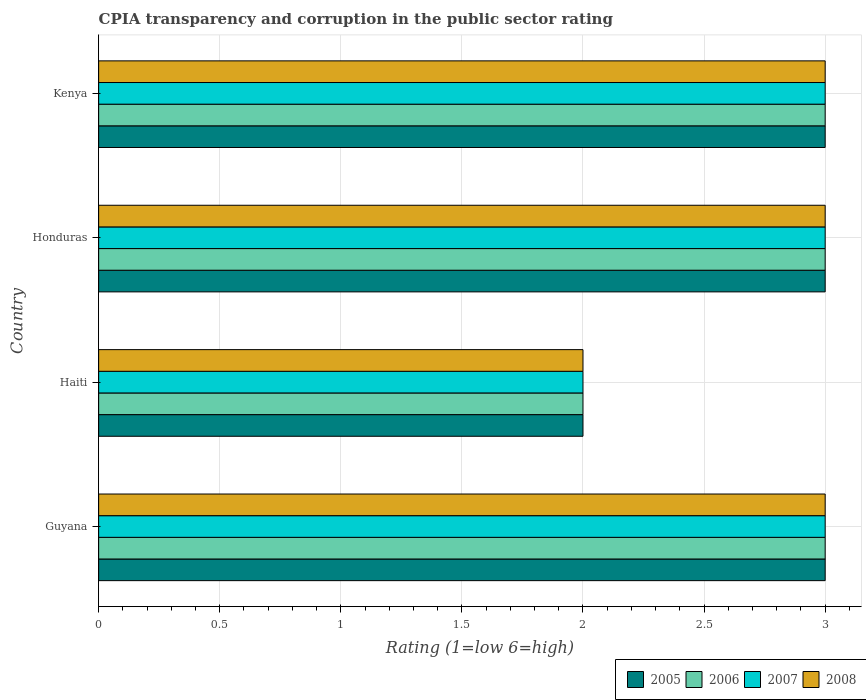How many groups of bars are there?
Provide a short and direct response. 4. How many bars are there on the 3rd tick from the top?
Make the answer very short. 4. What is the label of the 4th group of bars from the top?
Offer a terse response. Guyana. What is the CPIA rating in 2007 in Honduras?
Provide a short and direct response. 3. Across all countries, what is the minimum CPIA rating in 2006?
Provide a succinct answer. 2. In which country was the CPIA rating in 2007 maximum?
Your answer should be very brief. Guyana. In which country was the CPIA rating in 2007 minimum?
Your answer should be very brief. Haiti. What is the difference between the CPIA rating in 2008 in Haiti and that in Honduras?
Keep it short and to the point. -1. What is the difference between the CPIA rating in 2008 in Guyana and the CPIA rating in 2005 in Honduras?
Make the answer very short. 0. What is the average CPIA rating in 2005 per country?
Your answer should be compact. 2.75. In how many countries, is the CPIA rating in 2005 greater than 2.4 ?
Keep it short and to the point. 3. What is the ratio of the CPIA rating in 2008 in Honduras to that in Kenya?
Make the answer very short. 1. Is the CPIA rating in 2006 in Honduras less than that in Kenya?
Make the answer very short. No. Is the difference between the CPIA rating in 2006 in Guyana and Kenya greater than the difference between the CPIA rating in 2005 in Guyana and Kenya?
Offer a very short reply. No. What is the difference between the highest and the lowest CPIA rating in 2008?
Give a very brief answer. 1. In how many countries, is the CPIA rating in 2007 greater than the average CPIA rating in 2007 taken over all countries?
Keep it short and to the point. 3. Is the sum of the CPIA rating in 2007 in Haiti and Kenya greater than the maximum CPIA rating in 2008 across all countries?
Your answer should be very brief. Yes. Is it the case that in every country, the sum of the CPIA rating in 2006 and CPIA rating in 2005 is greater than the CPIA rating in 2008?
Offer a terse response. Yes. Are all the bars in the graph horizontal?
Keep it short and to the point. Yes. What is the difference between two consecutive major ticks on the X-axis?
Offer a terse response. 0.5. Does the graph contain any zero values?
Your response must be concise. No. Does the graph contain grids?
Offer a terse response. Yes. Where does the legend appear in the graph?
Your answer should be compact. Bottom right. What is the title of the graph?
Give a very brief answer. CPIA transparency and corruption in the public sector rating. What is the label or title of the Y-axis?
Make the answer very short. Country. What is the Rating (1=low 6=high) of 2008 in Guyana?
Your answer should be very brief. 3. What is the Rating (1=low 6=high) of 2007 in Haiti?
Provide a short and direct response. 2. What is the Rating (1=low 6=high) in 2005 in Honduras?
Offer a very short reply. 3. What is the Rating (1=low 6=high) in 2006 in Honduras?
Provide a short and direct response. 3. What is the Rating (1=low 6=high) in 2008 in Honduras?
Give a very brief answer. 3. What is the Rating (1=low 6=high) of 2008 in Kenya?
Your answer should be very brief. 3. Across all countries, what is the maximum Rating (1=low 6=high) in 2005?
Provide a succinct answer. 3. Across all countries, what is the maximum Rating (1=low 6=high) of 2006?
Provide a succinct answer. 3. Across all countries, what is the maximum Rating (1=low 6=high) of 2007?
Ensure brevity in your answer.  3. Across all countries, what is the minimum Rating (1=low 6=high) in 2006?
Offer a very short reply. 2. Across all countries, what is the minimum Rating (1=low 6=high) of 2007?
Give a very brief answer. 2. What is the total Rating (1=low 6=high) of 2006 in the graph?
Your answer should be compact. 11. What is the difference between the Rating (1=low 6=high) of 2005 in Guyana and that in Haiti?
Your answer should be compact. 1. What is the difference between the Rating (1=low 6=high) of 2006 in Guyana and that in Haiti?
Offer a terse response. 1. What is the difference between the Rating (1=low 6=high) in 2007 in Guyana and that in Haiti?
Provide a succinct answer. 1. What is the difference between the Rating (1=low 6=high) of 2008 in Guyana and that in Haiti?
Make the answer very short. 1. What is the difference between the Rating (1=low 6=high) of 2005 in Guyana and that in Honduras?
Your answer should be compact. 0. What is the difference between the Rating (1=low 6=high) in 2008 in Guyana and that in Honduras?
Your answer should be very brief. 0. What is the difference between the Rating (1=low 6=high) of 2006 in Guyana and that in Kenya?
Make the answer very short. 0. What is the difference between the Rating (1=low 6=high) in 2007 in Guyana and that in Kenya?
Your answer should be very brief. 0. What is the difference between the Rating (1=low 6=high) in 2008 in Guyana and that in Kenya?
Keep it short and to the point. 0. What is the difference between the Rating (1=low 6=high) in 2007 in Haiti and that in Honduras?
Your response must be concise. -1. What is the difference between the Rating (1=low 6=high) in 2008 in Haiti and that in Honduras?
Keep it short and to the point. -1. What is the difference between the Rating (1=low 6=high) of 2005 in Haiti and that in Kenya?
Give a very brief answer. -1. What is the difference between the Rating (1=low 6=high) in 2006 in Haiti and that in Kenya?
Your answer should be very brief. -1. What is the difference between the Rating (1=low 6=high) of 2008 in Haiti and that in Kenya?
Make the answer very short. -1. What is the difference between the Rating (1=low 6=high) in 2005 in Honduras and that in Kenya?
Keep it short and to the point. 0. What is the difference between the Rating (1=low 6=high) in 2006 in Honduras and that in Kenya?
Your answer should be compact. 0. What is the difference between the Rating (1=low 6=high) of 2005 in Guyana and the Rating (1=low 6=high) of 2006 in Haiti?
Offer a terse response. 1. What is the difference between the Rating (1=low 6=high) in 2005 in Guyana and the Rating (1=low 6=high) in 2008 in Haiti?
Keep it short and to the point. 1. What is the difference between the Rating (1=low 6=high) of 2005 in Guyana and the Rating (1=low 6=high) of 2006 in Honduras?
Your response must be concise. 0. What is the difference between the Rating (1=low 6=high) in 2005 in Guyana and the Rating (1=low 6=high) in 2008 in Honduras?
Your response must be concise. 0. What is the difference between the Rating (1=low 6=high) of 2006 in Guyana and the Rating (1=low 6=high) of 2007 in Honduras?
Keep it short and to the point. 0. What is the difference between the Rating (1=low 6=high) in 2006 in Guyana and the Rating (1=low 6=high) in 2008 in Honduras?
Give a very brief answer. 0. What is the difference between the Rating (1=low 6=high) in 2005 in Guyana and the Rating (1=low 6=high) in 2006 in Kenya?
Your answer should be very brief. 0. What is the difference between the Rating (1=low 6=high) in 2006 in Guyana and the Rating (1=low 6=high) in 2007 in Kenya?
Make the answer very short. 0. What is the difference between the Rating (1=low 6=high) in 2007 in Haiti and the Rating (1=low 6=high) in 2008 in Honduras?
Provide a succinct answer. -1. What is the difference between the Rating (1=low 6=high) in 2006 in Haiti and the Rating (1=low 6=high) in 2007 in Kenya?
Keep it short and to the point. -1. What is the difference between the Rating (1=low 6=high) in 2007 in Haiti and the Rating (1=low 6=high) in 2008 in Kenya?
Provide a short and direct response. -1. What is the difference between the Rating (1=low 6=high) in 2005 in Honduras and the Rating (1=low 6=high) in 2007 in Kenya?
Your response must be concise. 0. What is the average Rating (1=low 6=high) in 2005 per country?
Provide a succinct answer. 2.75. What is the average Rating (1=low 6=high) in 2006 per country?
Offer a terse response. 2.75. What is the average Rating (1=low 6=high) in 2007 per country?
Offer a very short reply. 2.75. What is the average Rating (1=low 6=high) in 2008 per country?
Give a very brief answer. 2.75. What is the difference between the Rating (1=low 6=high) of 2007 and Rating (1=low 6=high) of 2008 in Guyana?
Provide a short and direct response. 0. What is the difference between the Rating (1=low 6=high) in 2005 and Rating (1=low 6=high) in 2006 in Haiti?
Your answer should be compact. 0. What is the difference between the Rating (1=low 6=high) of 2005 and Rating (1=low 6=high) of 2007 in Haiti?
Offer a very short reply. 0. What is the difference between the Rating (1=low 6=high) of 2005 and Rating (1=low 6=high) of 2008 in Haiti?
Keep it short and to the point. 0. What is the difference between the Rating (1=low 6=high) in 2006 and Rating (1=low 6=high) in 2008 in Haiti?
Keep it short and to the point. 0. What is the difference between the Rating (1=low 6=high) in 2005 and Rating (1=low 6=high) in 2006 in Honduras?
Your answer should be compact. 0. What is the difference between the Rating (1=low 6=high) in 2006 and Rating (1=low 6=high) in 2008 in Honduras?
Offer a very short reply. 0. What is the difference between the Rating (1=low 6=high) in 2007 and Rating (1=low 6=high) in 2008 in Honduras?
Offer a terse response. 0. What is the difference between the Rating (1=low 6=high) in 2005 and Rating (1=low 6=high) in 2006 in Kenya?
Give a very brief answer. 0. What is the difference between the Rating (1=low 6=high) of 2005 and Rating (1=low 6=high) of 2007 in Kenya?
Offer a terse response. 0. What is the difference between the Rating (1=low 6=high) of 2005 and Rating (1=low 6=high) of 2008 in Kenya?
Give a very brief answer. 0. What is the difference between the Rating (1=low 6=high) in 2006 and Rating (1=low 6=high) in 2008 in Kenya?
Ensure brevity in your answer.  0. What is the ratio of the Rating (1=low 6=high) of 2005 in Guyana to that in Haiti?
Ensure brevity in your answer.  1.5. What is the ratio of the Rating (1=low 6=high) in 2008 in Guyana to that in Haiti?
Provide a short and direct response. 1.5. What is the ratio of the Rating (1=low 6=high) of 2006 in Guyana to that in Honduras?
Give a very brief answer. 1. What is the ratio of the Rating (1=low 6=high) in 2007 in Guyana to that in Honduras?
Give a very brief answer. 1. What is the ratio of the Rating (1=low 6=high) of 2008 in Guyana to that in Honduras?
Provide a short and direct response. 1. What is the ratio of the Rating (1=low 6=high) in 2006 in Guyana to that in Kenya?
Offer a terse response. 1. What is the ratio of the Rating (1=low 6=high) in 2007 in Guyana to that in Kenya?
Keep it short and to the point. 1. What is the ratio of the Rating (1=low 6=high) of 2008 in Guyana to that in Kenya?
Offer a terse response. 1. What is the ratio of the Rating (1=low 6=high) in 2006 in Haiti to that in Honduras?
Keep it short and to the point. 0.67. What is the ratio of the Rating (1=low 6=high) in 2007 in Haiti to that in Honduras?
Ensure brevity in your answer.  0.67. What is the ratio of the Rating (1=low 6=high) of 2008 in Haiti to that in Honduras?
Ensure brevity in your answer.  0.67. What is the ratio of the Rating (1=low 6=high) of 2005 in Haiti to that in Kenya?
Offer a very short reply. 0.67. What is the ratio of the Rating (1=low 6=high) in 2006 in Haiti to that in Kenya?
Offer a terse response. 0.67. What is the ratio of the Rating (1=low 6=high) of 2007 in Haiti to that in Kenya?
Make the answer very short. 0.67. What is the ratio of the Rating (1=low 6=high) of 2005 in Honduras to that in Kenya?
Your response must be concise. 1. What is the ratio of the Rating (1=low 6=high) in 2006 in Honduras to that in Kenya?
Provide a succinct answer. 1. What is the difference between the highest and the second highest Rating (1=low 6=high) in 2005?
Your answer should be very brief. 0. What is the difference between the highest and the second highest Rating (1=low 6=high) of 2006?
Keep it short and to the point. 0. What is the difference between the highest and the second highest Rating (1=low 6=high) in 2008?
Offer a very short reply. 0. What is the difference between the highest and the lowest Rating (1=low 6=high) of 2007?
Keep it short and to the point. 1. 